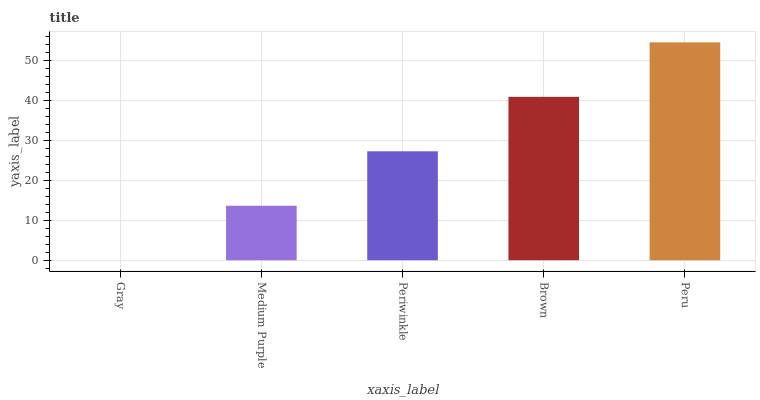Is Gray the minimum?
Answer yes or no. Yes. Is Peru the maximum?
Answer yes or no. Yes. Is Medium Purple the minimum?
Answer yes or no. No. Is Medium Purple the maximum?
Answer yes or no. No. Is Medium Purple greater than Gray?
Answer yes or no. Yes. Is Gray less than Medium Purple?
Answer yes or no. Yes. Is Gray greater than Medium Purple?
Answer yes or no. No. Is Medium Purple less than Gray?
Answer yes or no. No. Is Periwinkle the high median?
Answer yes or no. Yes. Is Periwinkle the low median?
Answer yes or no. Yes. Is Gray the high median?
Answer yes or no. No. Is Gray the low median?
Answer yes or no. No. 